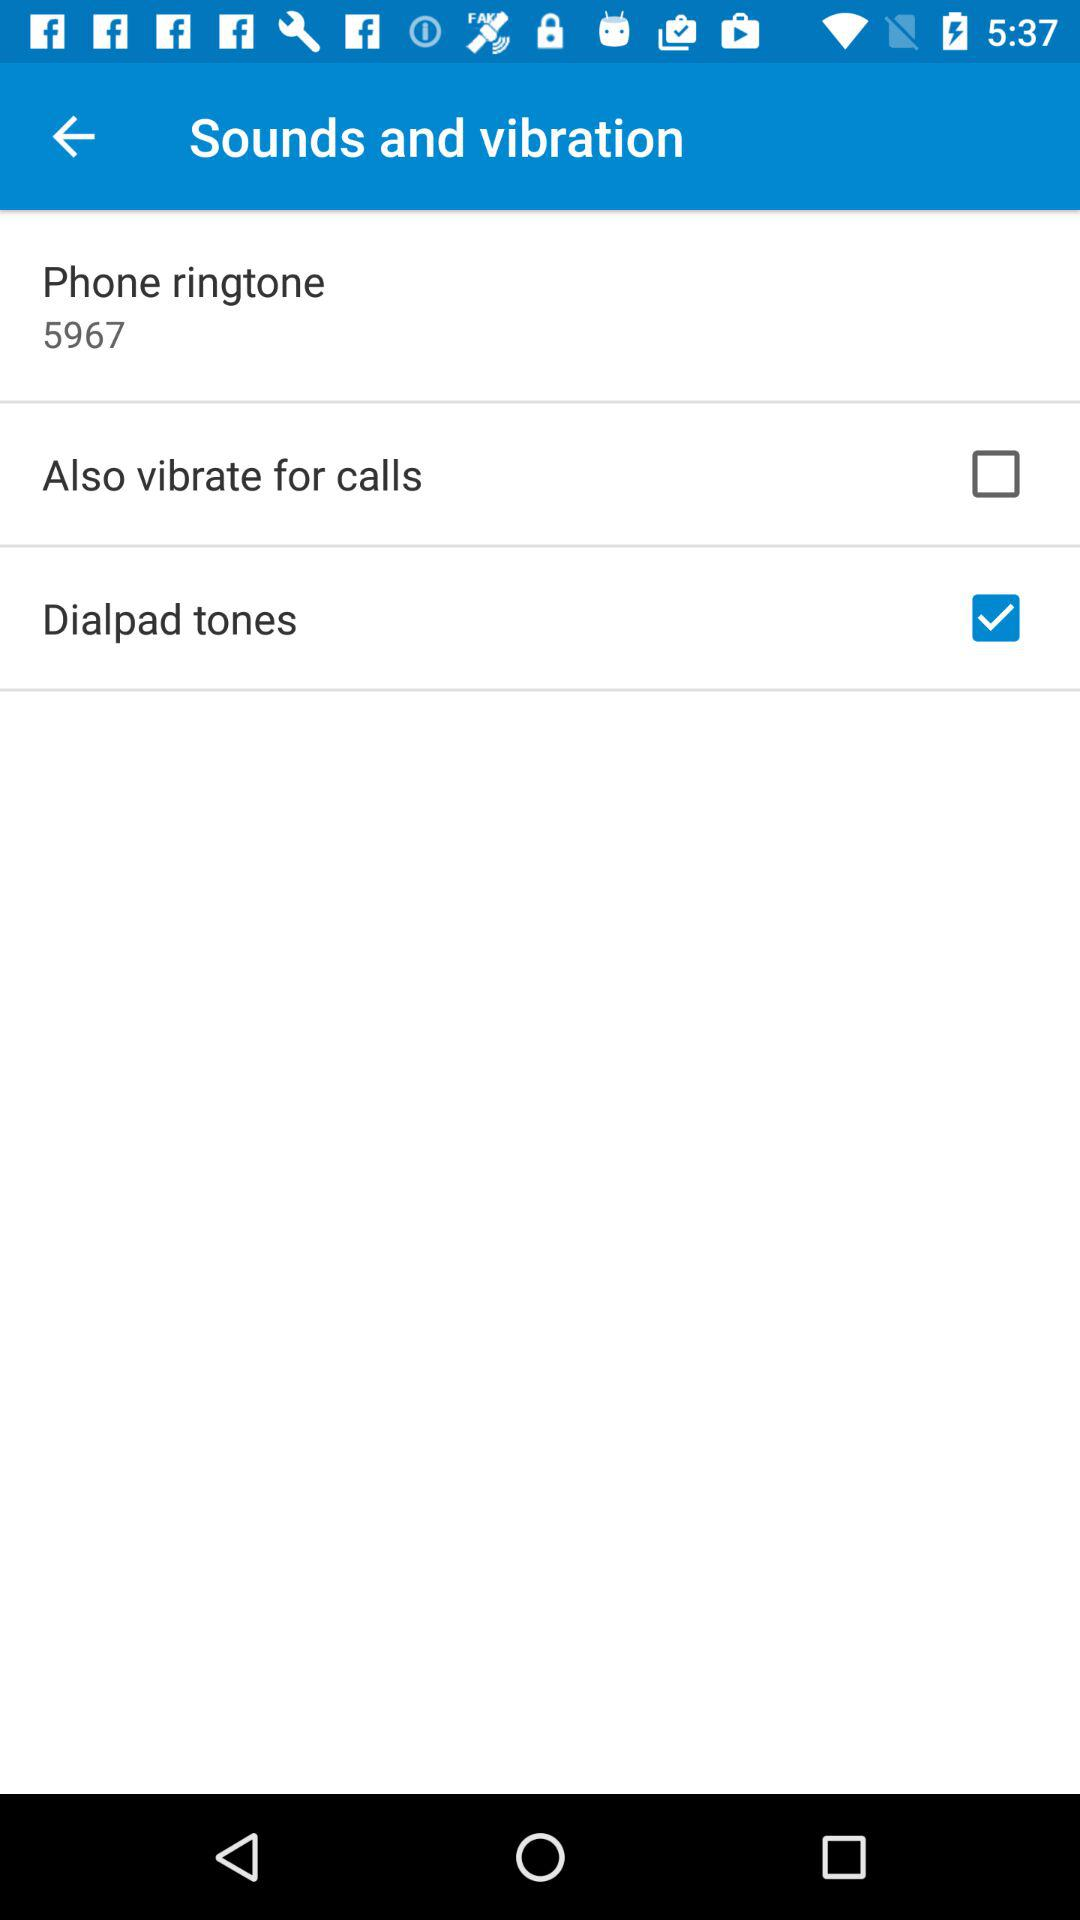What is the status of "Also vibrate for calls"? The status is "off". 